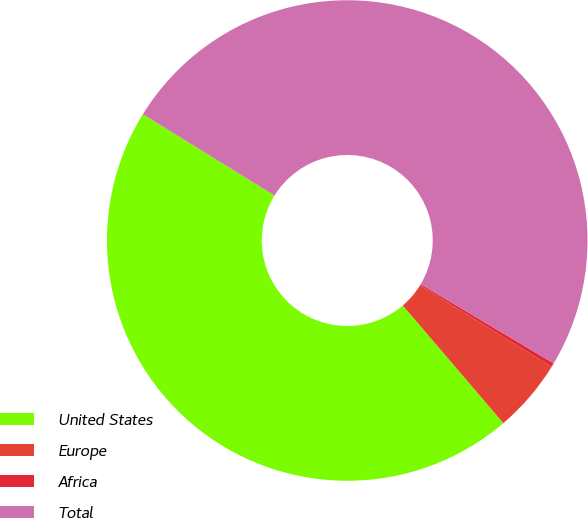<chart> <loc_0><loc_0><loc_500><loc_500><pie_chart><fcel>United States<fcel>Europe<fcel>Africa<fcel>Total<nl><fcel>45.06%<fcel>4.94%<fcel>0.26%<fcel>49.74%<nl></chart> 